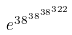<formula> <loc_0><loc_0><loc_500><loc_500>e ^ { 3 8 ^ { 3 8 ^ { 3 8 ^ { 3 2 2 } } } }</formula> 